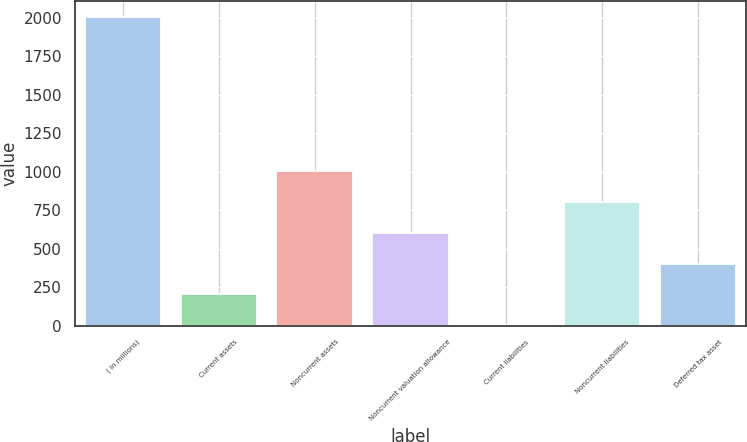Convert chart to OTSL. <chart><loc_0><loc_0><loc_500><loc_500><bar_chart><fcel>( in millions)<fcel>Current assets<fcel>Noncurrent assets<fcel>Noncurrent valuation allowance<fcel>Current liabilities<fcel>Noncurrent liabilities<fcel>Deferred tax asset<nl><fcel>2007<fcel>202.95<fcel>1004.75<fcel>603.85<fcel>2.5<fcel>804.3<fcel>403.4<nl></chart> 